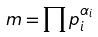<formula> <loc_0><loc_0><loc_500><loc_500>m = \prod p _ { i } ^ { \alpha _ { i } }</formula> 